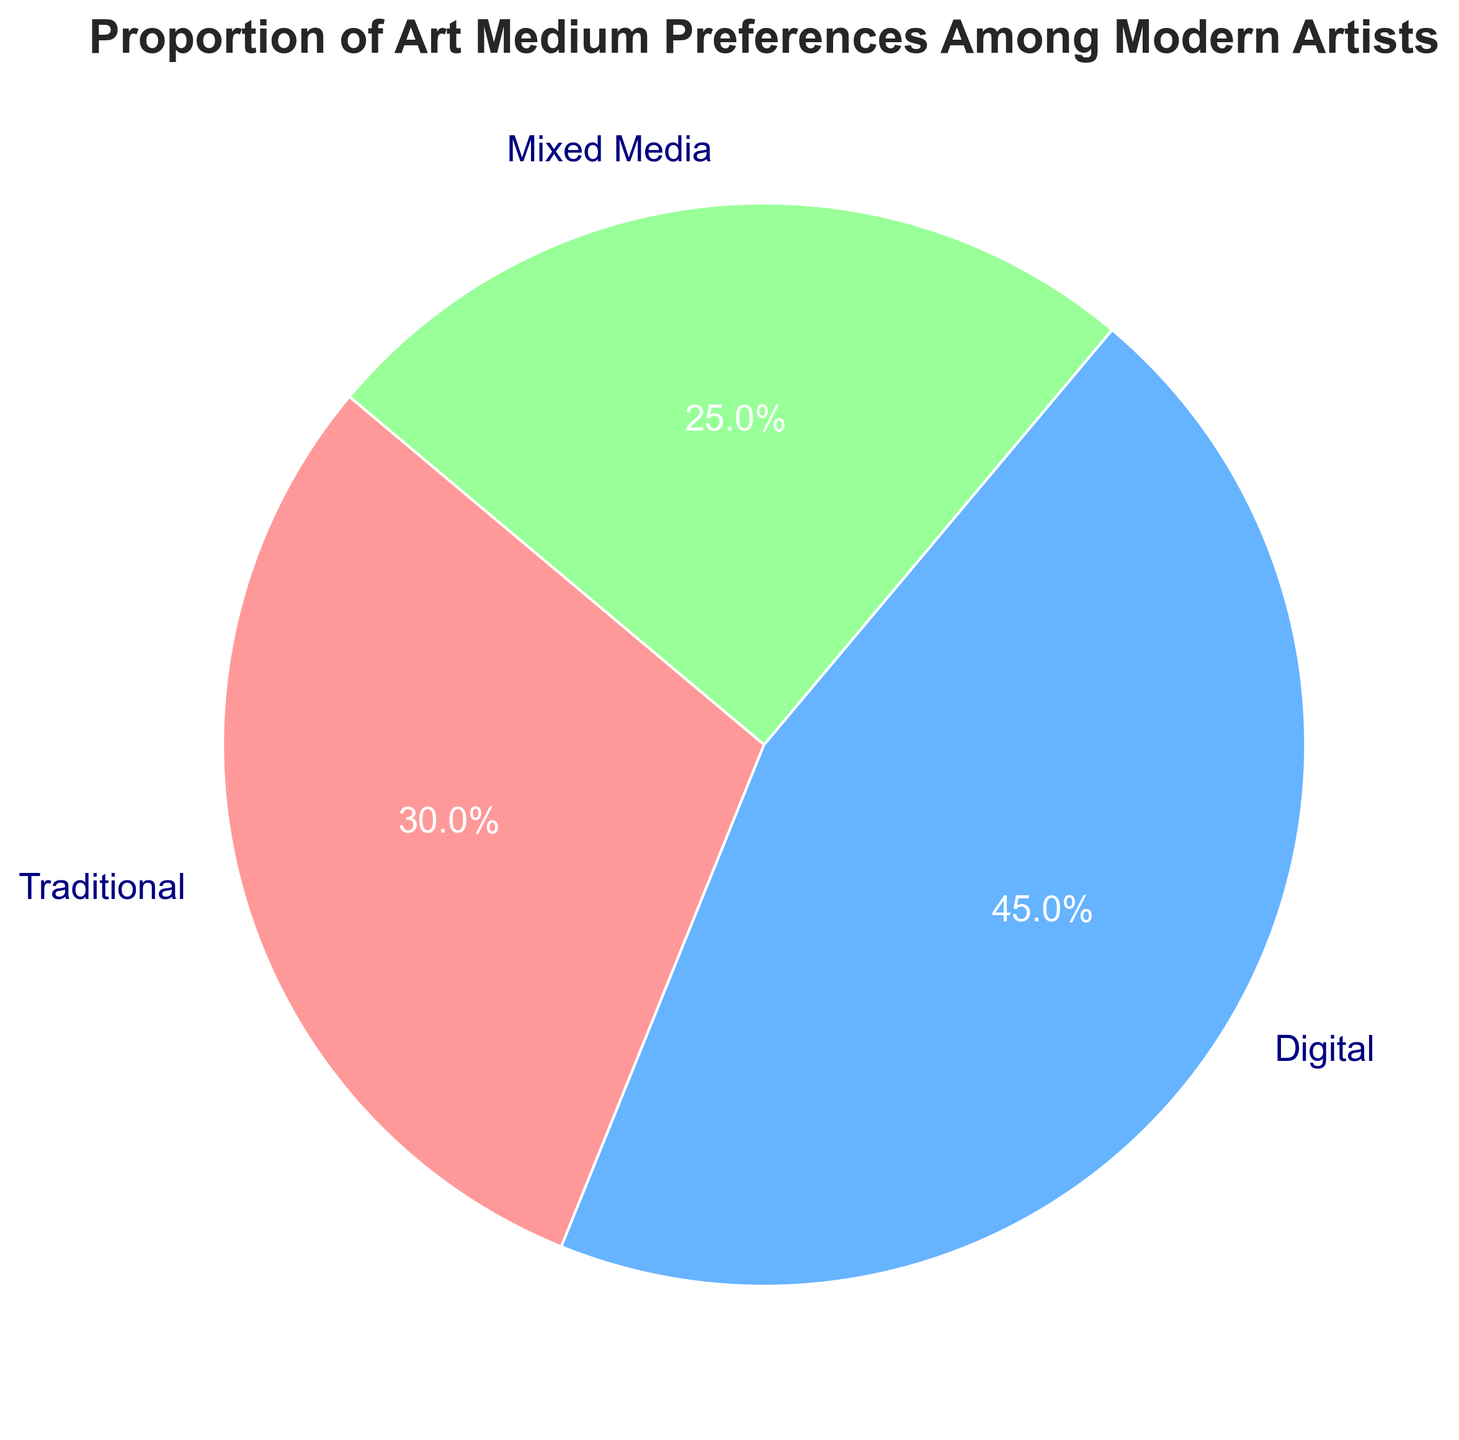What proportion of modern artists prefer digital art? The pie chart directly shows the proportion of each art medium preference. The slice representing digital art has a label indicating 45%.
Answer: 45% Which art medium has the smallest preference among modern artists? The pie chart label for mixed media shows 25%, which is smaller than the proportions for digital (45%) and traditional (30%) art.
Answer: Mixed Media What is the sum of the proportions of artists who prefer traditional and mixed media art? The pie chart shows that the proportion for traditional art is 30% and for mixed media is 25%. Adding these together: 30% + 25% = 55%.
Answer: 55% Is the proportion of artists preferring digital art greater than the combined proportion of those preferring traditional and mixed media art? From the pie chart, the digital art proportion is 45%. The combined proportion for traditional and mixed media is 30% + 25% = 55%. Since 45% < 55%, the proportion of digital art is not greater.
Answer: No What color represents the slice for traditional art in the pie chart? The pie chart visually indicates the color of each slice. The slice for traditional art is shown in a light red color.
Answer: Light Red If you were to combine the slices for traditional and digital art, what fraction of the chart would they represent in total? The chart shows traditional art as 30% and digital art as 45%. Combined, they make 30% + 45% = 75%. This equivalent fraction is 75%.
Answer: 75% How does the proportion of artists favoring digital art compare to those favoring traditional art? According to the pie chart, the proportion for digital art is 45% while for traditional art it is 30%. Since 45% > 30%, more artists favor digital art.
Answer: More for Digital Art 